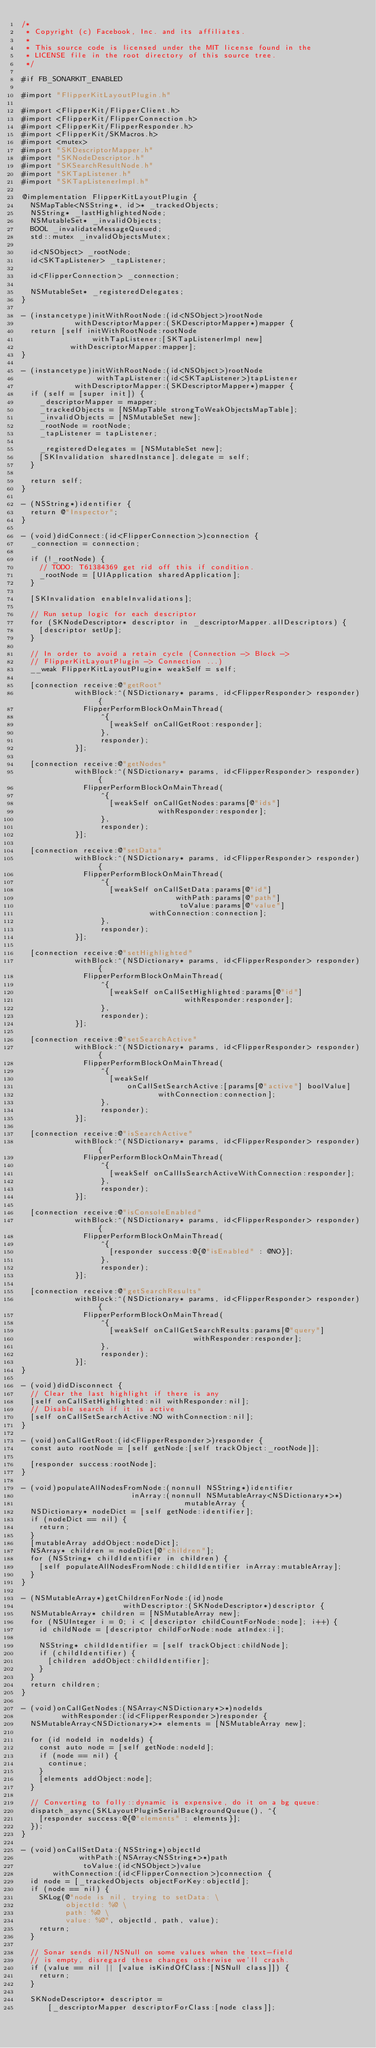Convert code to text. <code><loc_0><loc_0><loc_500><loc_500><_ObjectiveC_>/*
 * Copyright (c) Facebook, Inc. and its affiliates.
 *
 * This source code is licensed under the MIT license found in the
 * LICENSE file in the root directory of this source tree.
 */

#if FB_SONARKIT_ENABLED

#import "FlipperKitLayoutPlugin.h"

#import <FlipperKit/FlipperClient.h>
#import <FlipperKit/FlipperConnection.h>
#import <FlipperKit/FlipperResponder.h>
#import <FlipperKit/SKMacros.h>
#import <mutex>
#import "SKDescriptorMapper.h"
#import "SKNodeDescriptor.h"
#import "SKSearchResultNode.h"
#import "SKTapListener.h"
#import "SKTapListenerImpl.h"

@implementation FlipperKitLayoutPlugin {
  NSMapTable<NSString*, id>* _trackedObjects;
  NSString* _lastHighlightedNode;
  NSMutableSet* _invalidObjects;
  BOOL _invalidateMessageQueued;
  std::mutex _invalidObjectsMutex;

  id<NSObject> _rootNode;
  id<SKTapListener> _tapListener;

  id<FlipperConnection> _connection;

  NSMutableSet* _registeredDelegates;
}

- (instancetype)initWithRootNode:(id<NSObject>)rootNode
            withDescriptorMapper:(SKDescriptorMapper*)mapper {
  return [self initWithRootNode:rootNode
                withTapListener:[SKTapListenerImpl new]
           withDescriptorMapper:mapper];
}

- (instancetype)initWithRootNode:(id<NSObject>)rootNode
                 withTapListener:(id<SKTapListener>)tapListener
            withDescriptorMapper:(SKDescriptorMapper*)mapper {
  if (self = [super init]) {
    _descriptorMapper = mapper;
    _trackedObjects = [NSMapTable strongToWeakObjectsMapTable];
    _invalidObjects = [NSMutableSet new];
    _rootNode = rootNode;
    _tapListener = tapListener;

    _registeredDelegates = [NSMutableSet new];
    [SKInvalidation sharedInstance].delegate = self;
  }

  return self;
}

- (NSString*)identifier {
  return @"Inspector";
}

- (void)didConnect:(id<FlipperConnection>)connection {
  _connection = connection;

  if (!_rootNode) {
    // TODO: T61384369 get rid off this if condition.
    _rootNode = [UIApplication sharedApplication];
  }

  [SKInvalidation enableInvalidations];

  // Run setup logic for each descriptor
  for (SKNodeDescriptor* descriptor in _descriptorMapper.allDescriptors) {
    [descriptor setUp];
  }

  // In order to avoid a retain cycle (Connection -> Block ->
  // FlipperKitLayoutPlugin -> Connection ...)
  __weak FlipperKitLayoutPlugin* weakSelf = self;

  [connection receive:@"getRoot"
            withBlock:^(NSDictionary* params, id<FlipperResponder> responder) {
              FlipperPerformBlockOnMainThread(
                  ^{
                    [weakSelf onCallGetRoot:responder];
                  },
                  responder);
            }];

  [connection receive:@"getNodes"
            withBlock:^(NSDictionary* params, id<FlipperResponder> responder) {
              FlipperPerformBlockOnMainThread(
                  ^{
                    [weakSelf onCallGetNodes:params[@"ids"]
                               withResponder:responder];
                  },
                  responder);
            }];

  [connection receive:@"setData"
            withBlock:^(NSDictionary* params, id<FlipperResponder> responder) {
              FlipperPerformBlockOnMainThread(
                  ^{
                    [weakSelf onCallSetData:params[@"id"]
                                   withPath:params[@"path"]
                                    toValue:params[@"value"]
                             withConnection:connection];
                  },
                  responder);
            }];

  [connection receive:@"setHighlighted"
            withBlock:^(NSDictionary* params, id<FlipperResponder> responder) {
              FlipperPerformBlockOnMainThread(
                  ^{
                    [weakSelf onCallSetHighlighted:params[@"id"]
                                     withResponder:responder];
                  },
                  responder);
            }];

  [connection receive:@"setSearchActive"
            withBlock:^(NSDictionary* params, id<FlipperResponder> responder) {
              FlipperPerformBlockOnMainThread(
                  ^{
                    [weakSelf
                        onCallSetSearchActive:[params[@"active"] boolValue]
                               withConnection:connection];
                  },
                  responder);
            }];

  [connection receive:@"isSearchActive"
            withBlock:^(NSDictionary* params, id<FlipperResponder> responder) {
              FlipperPerformBlockOnMainThread(
                  ^{
                    [weakSelf onCallIsSearchActiveWithConnection:responder];
                  },
                  responder);
            }];

  [connection receive:@"isConsoleEnabled"
            withBlock:^(NSDictionary* params, id<FlipperResponder> responder) {
              FlipperPerformBlockOnMainThread(
                  ^{
                    [responder success:@{@"isEnabled" : @NO}];
                  },
                  responder);
            }];

  [connection receive:@"getSearchResults"
            withBlock:^(NSDictionary* params, id<FlipperResponder> responder) {
              FlipperPerformBlockOnMainThread(
                  ^{
                    [weakSelf onCallGetSearchResults:params[@"query"]
                                       withResponder:responder];
                  },
                  responder);
            }];
}

- (void)didDisconnect {
  // Clear the last highlight if there is any
  [self onCallSetHighlighted:nil withResponder:nil];
  // Disable search if it is active
  [self onCallSetSearchActive:NO withConnection:nil];
}

- (void)onCallGetRoot:(id<FlipperResponder>)responder {
  const auto rootNode = [self getNode:[self trackObject:_rootNode]];

  [responder success:rootNode];
}

- (void)populateAllNodesFromNode:(nonnull NSString*)identifier
                         inArray:(nonnull NSMutableArray<NSDictionary*>*)
                                     mutableArray {
  NSDictionary* nodeDict = [self getNode:identifier];
  if (nodeDict == nil) {
    return;
  }
  [mutableArray addObject:nodeDict];
  NSArray* children = nodeDict[@"children"];
  for (NSString* childIdentifier in children) {
    [self populateAllNodesFromNode:childIdentifier inArray:mutableArray];
  }
}

- (NSMutableArray*)getChildrenForNode:(id)node
                       withDescriptor:(SKNodeDescriptor*)descriptor {
  NSMutableArray* children = [NSMutableArray new];
  for (NSUInteger i = 0; i < [descriptor childCountForNode:node]; i++) {
    id childNode = [descriptor childForNode:node atIndex:i];

    NSString* childIdentifier = [self trackObject:childNode];
    if (childIdentifier) {
      [children addObject:childIdentifier];
    }
  }
  return children;
}

- (void)onCallGetNodes:(NSArray<NSDictionary*>*)nodeIds
         withResponder:(id<FlipperResponder>)responder {
  NSMutableArray<NSDictionary*>* elements = [NSMutableArray new];

  for (id nodeId in nodeIds) {
    const auto node = [self getNode:nodeId];
    if (node == nil) {
      continue;
    }
    [elements addObject:node];
  }

  // Converting to folly::dynamic is expensive, do it on a bg queue:
  dispatch_async(SKLayoutPluginSerialBackgroundQueue(), ^{
    [responder success:@{@"elements" : elements}];
  });
}

- (void)onCallSetData:(NSString*)objectId
             withPath:(NSArray<NSString*>*)path
              toValue:(id<NSObject>)value
       withConnection:(id<FlipperConnection>)connection {
  id node = [_trackedObjects objectForKey:objectId];
  if (node == nil) {
    SKLog(@"node is nil, trying to setData: \
          objectId: %@ \
          path: %@ \
          value: %@", objectId, path, value);
    return;
  }

  // Sonar sends nil/NSNull on some values when the text-field
  // is empty, disregard these changes otherwise we'll crash.
  if (value == nil || [value isKindOfClass:[NSNull class]]) {
    return;
  }

  SKNodeDescriptor* descriptor =
      [_descriptorMapper descriptorForClass:[node class]];
</code> 